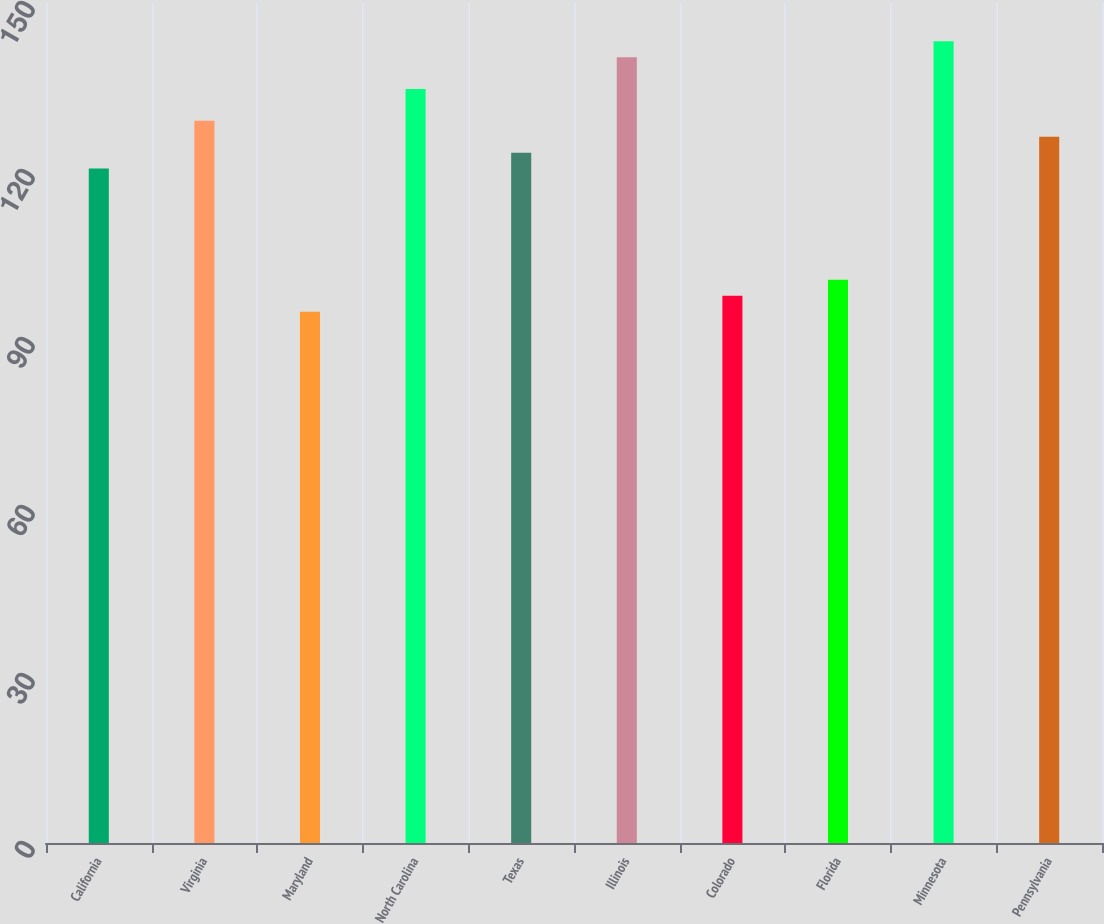<chart> <loc_0><loc_0><loc_500><loc_500><bar_chart><fcel>California<fcel>Virginia<fcel>Maryland<fcel>North Carolina<fcel>Texas<fcel>Illinois<fcel>Colorado<fcel>Florida<fcel>Minnesota<fcel>Pennsylvania<nl><fcel>120.44<fcel>128.96<fcel>94.88<fcel>134.64<fcel>123.28<fcel>140.32<fcel>97.72<fcel>100.56<fcel>143.16<fcel>126.12<nl></chart> 